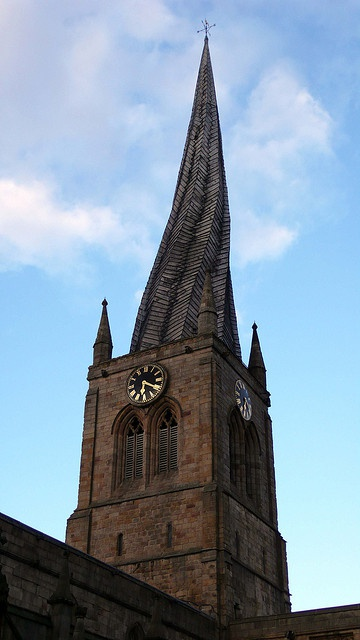Describe the objects in this image and their specific colors. I can see clock in lavender, black, gray, khaki, and tan tones and clock in lavender, gray, black, and darkgray tones in this image. 